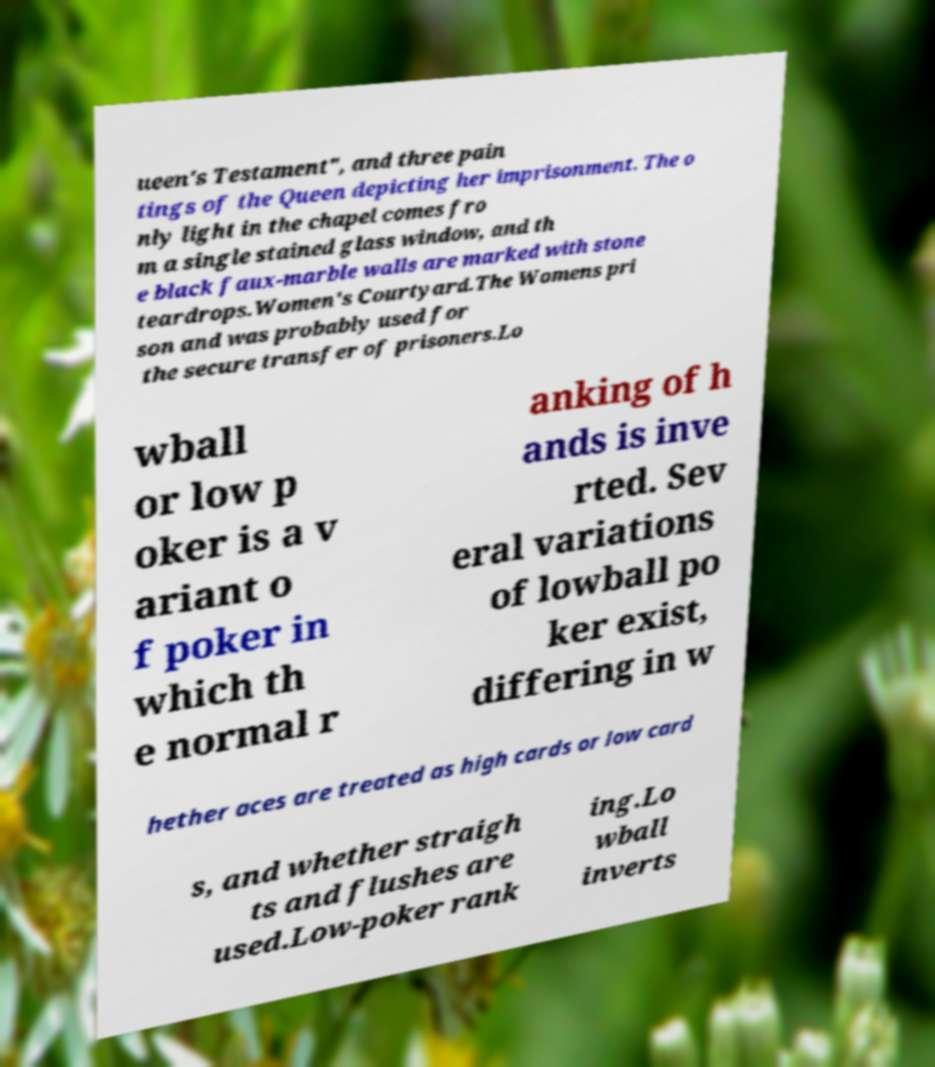I need the written content from this picture converted into text. Can you do that? ueen's Testament", and three pain tings of the Queen depicting her imprisonment. The o nly light in the chapel comes fro m a single stained glass window, and th e black faux-marble walls are marked with stone teardrops.Women's Courtyard.The Womens pri son and was probably used for the secure transfer of prisoners.Lo wball or low p oker is a v ariant o f poker in which th e normal r anking of h ands is inve rted. Sev eral variations of lowball po ker exist, differing in w hether aces are treated as high cards or low card s, and whether straigh ts and flushes are used.Low-poker rank ing.Lo wball inverts 